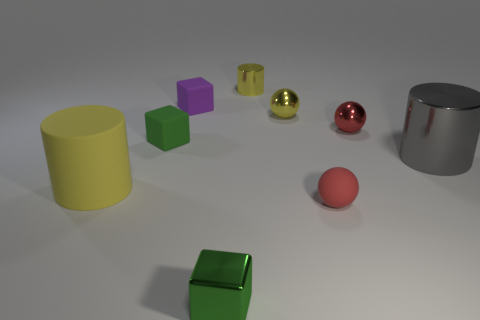What is the shape of the green thing that is left of the purple block?
Provide a succinct answer. Cube. Does the small purple rubber object have the same shape as the yellow rubber thing?
Give a very brief answer. No. Are there the same number of green rubber blocks in front of the yellow rubber thing and matte balls?
Your response must be concise. No. What shape is the gray metallic thing?
Keep it short and to the point. Cylinder. Are there any other things of the same color as the small matte ball?
Your answer should be compact. Yes. Is the size of the cylinder that is left of the metal cube the same as the thing that is on the right side of the red shiny ball?
Provide a short and direct response. Yes. There is a green thing behind the yellow cylinder that is in front of the large gray object; what is its shape?
Keep it short and to the point. Cube. There is a metal cube; is its size the same as the green thing that is behind the big yellow matte cylinder?
Ensure brevity in your answer.  Yes. There is a green block in front of the cylinder that is to the right of the yellow cylinder behind the yellow shiny ball; what is its size?
Ensure brevity in your answer.  Small. What number of objects are either small yellow shiny objects that are behind the purple matte object or blue blocks?
Keep it short and to the point. 1. 